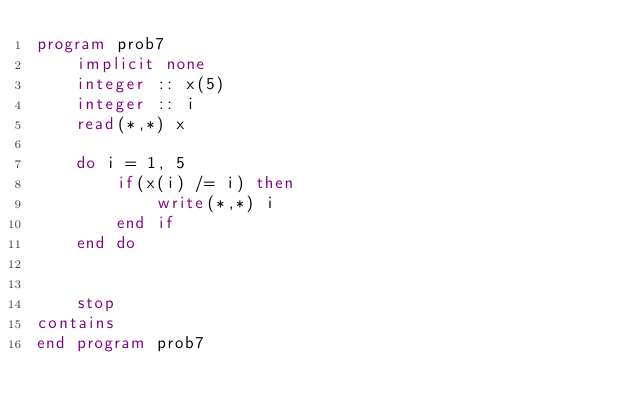<code> <loc_0><loc_0><loc_500><loc_500><_FORTRAN_>program prob7
    implicit none
    integer :: x(5)
    integer :: i
    read(*,*) x

    do i = 1, 5
        if(x(i) /= i) then
            write(*,*) i
        end if
    end do


    stop
contains
end program prob7</code> 